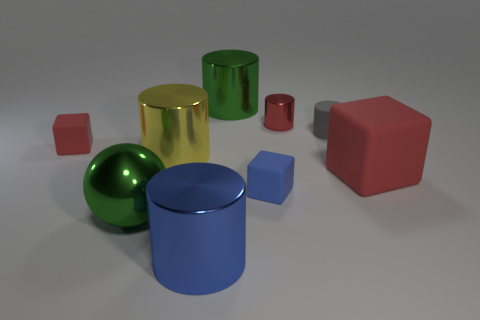Subtract 2 cylinders. How many cylinders are left? 3 Subtract all tiny matte cylinders. How many cylinders are left? 4 Subtract all purple cylinders. Subtract all blue cubes. How many cylinders are left? 5 Subtract all balls. How many objects are left? 8 Subtract 1 yellow cylinders. How many objects are left? 8 Subtract all gray rubber cylinders. Subtract all tiny rubber cylinders. How many objects are left? 7 Add 7 tiny matte objects. How many tiny matte objects are left? 10 Add 3 big blue shiny cylinders. How many big blue shiny cylinders exist? 4 